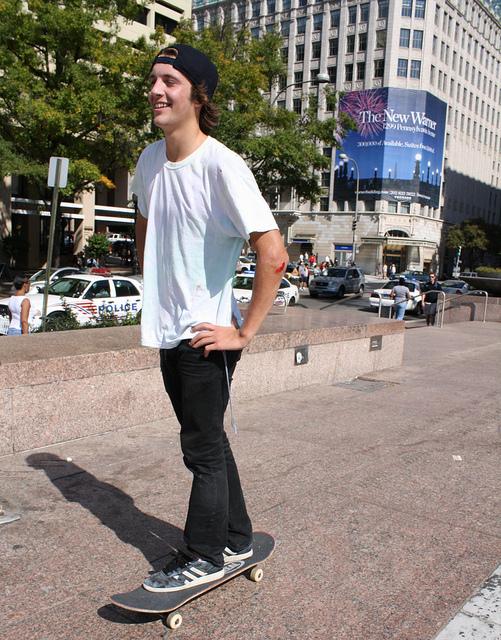Why is the man's hands on his hips?
Quick response, please. Balance. What color is the man's shirt?
Write a very short answer. White. What is this man riding on?
Keep it brief. Skateboard. 